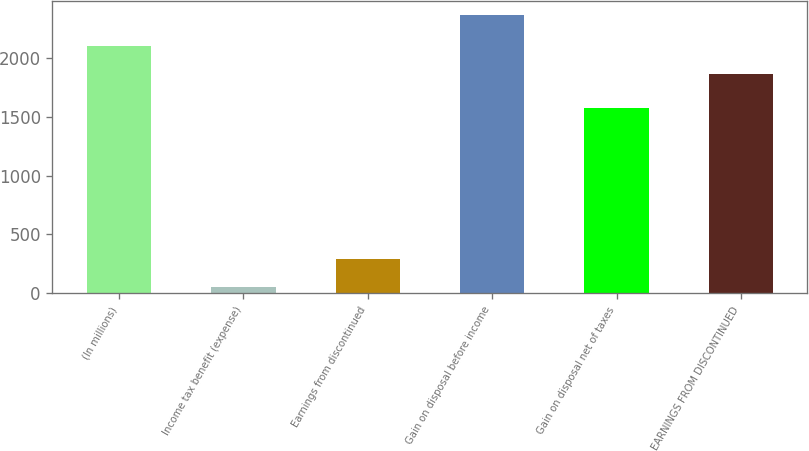Convert chart to OTSL. <chart><loc_0><loc_0><loc_500><loc_500><bar_chart><fcel>(In millions)<fcel>Income tax benefit (expense)<fcel>Earnings from discontinued<fcel>Gain on disposal before income<fcel>Gain on disposal net of taxes<fcel>EARNINGS FROM DISCONTINUED<nl><fcel>2097.6<fcel>56<fcel>289<fcel>2362<fcel>1578<fcel>1867<nl></chart> 